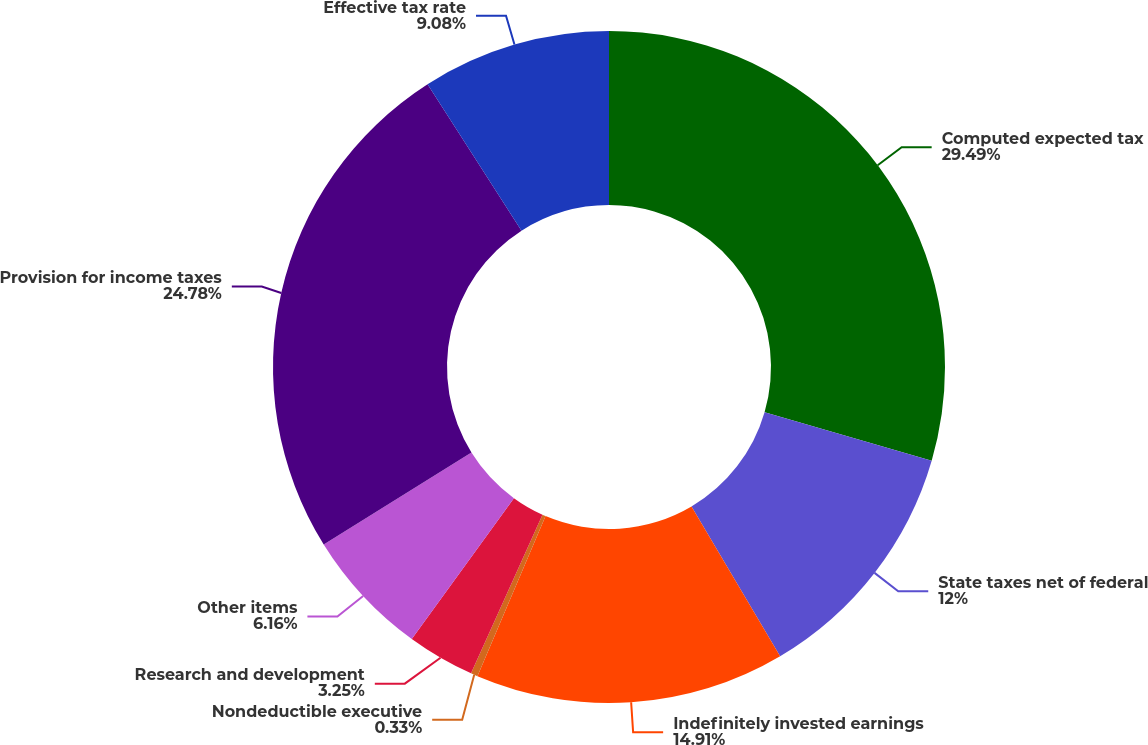<chart> <loc_0><loc_0><loc_500><loc_500><pie_chart><fcel>Computed expected tax<fcel>State taxes net of federal<fcel>Indefinitely invested earnings<fcel>Nondeductible executive<fcel>Research and development<fcel>Other items<fcel>Provision for income taxes<fcel>Effective tax rate<nl><fcel>29.5%<fcel>12.0%<fcel>14.91%<fcel>0.33%<fcel>3.25%<fcel>6.16%<fcel>24.78%<fcel>9.08%<nl></chart> 